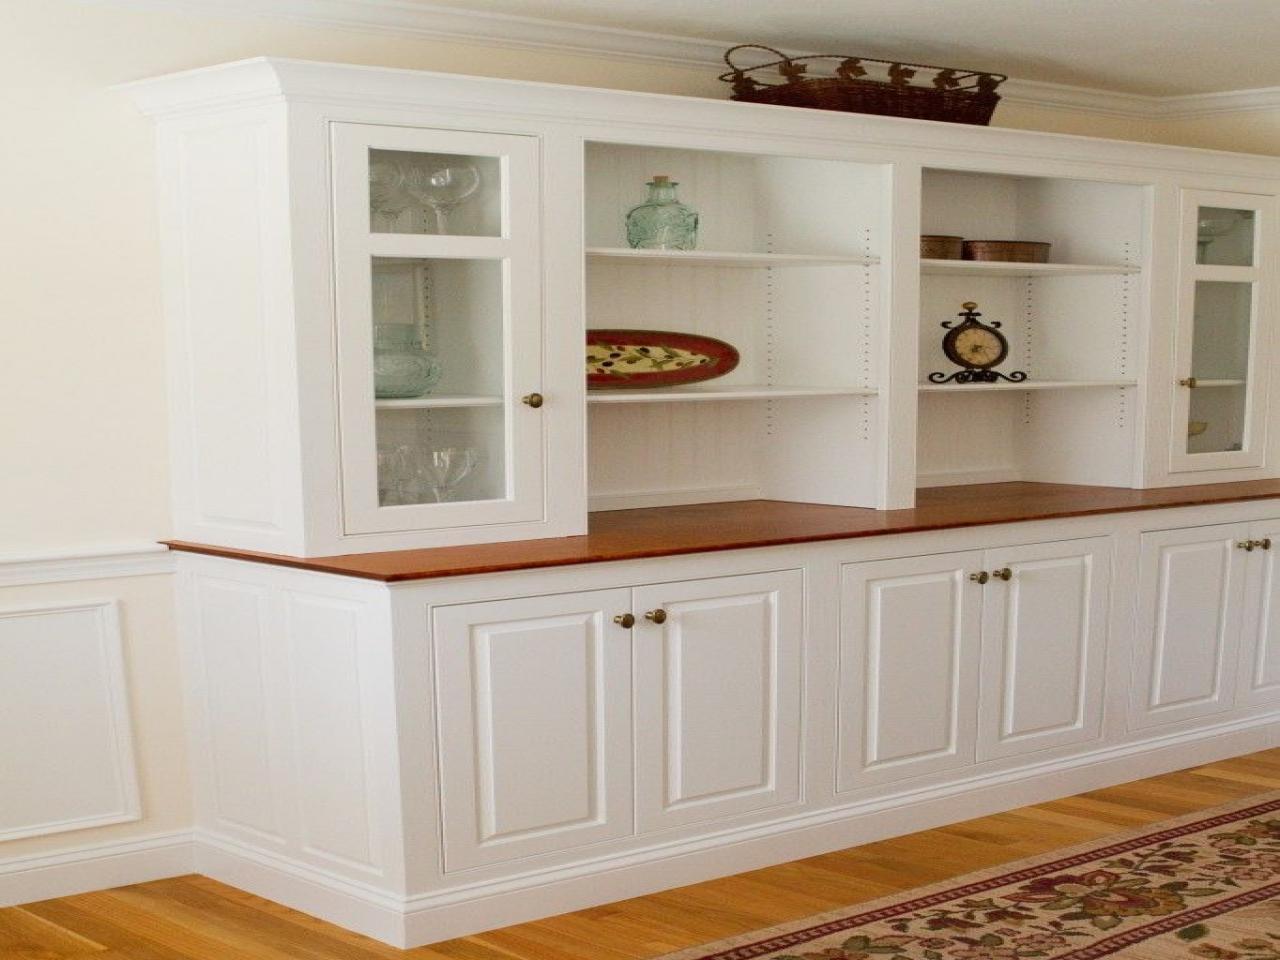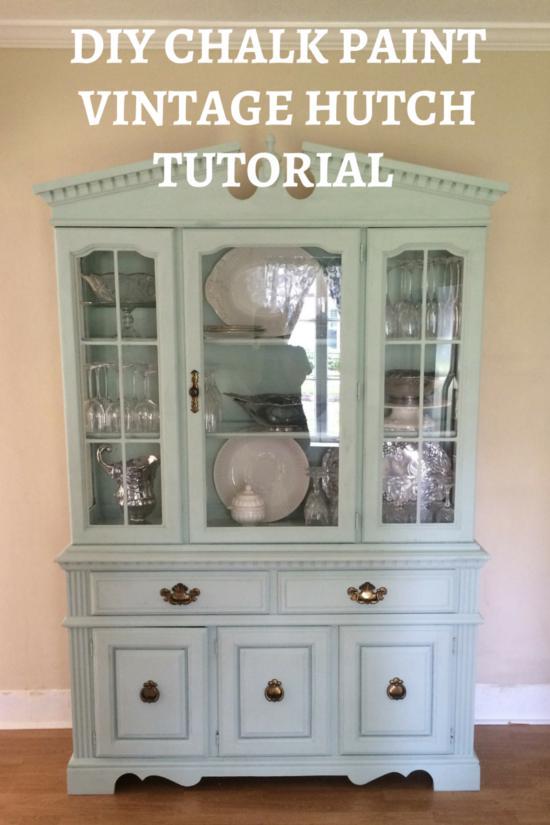The first image is the image on the left, the second image is the image on the right. Analyze the images presented: Is the assertion "The cabinet in the right image is light green." valid? Answer yes or no. Yes. The first image is the image on the left, the second image is the image on the right. Assess this claim about the two images: "A wooden cabinet in one image stands of long spindle legs, and has solid panels on each side of a wide glass door, and a full-width drawer with two pulls.". Correct or not? Answer yes or no. No. 